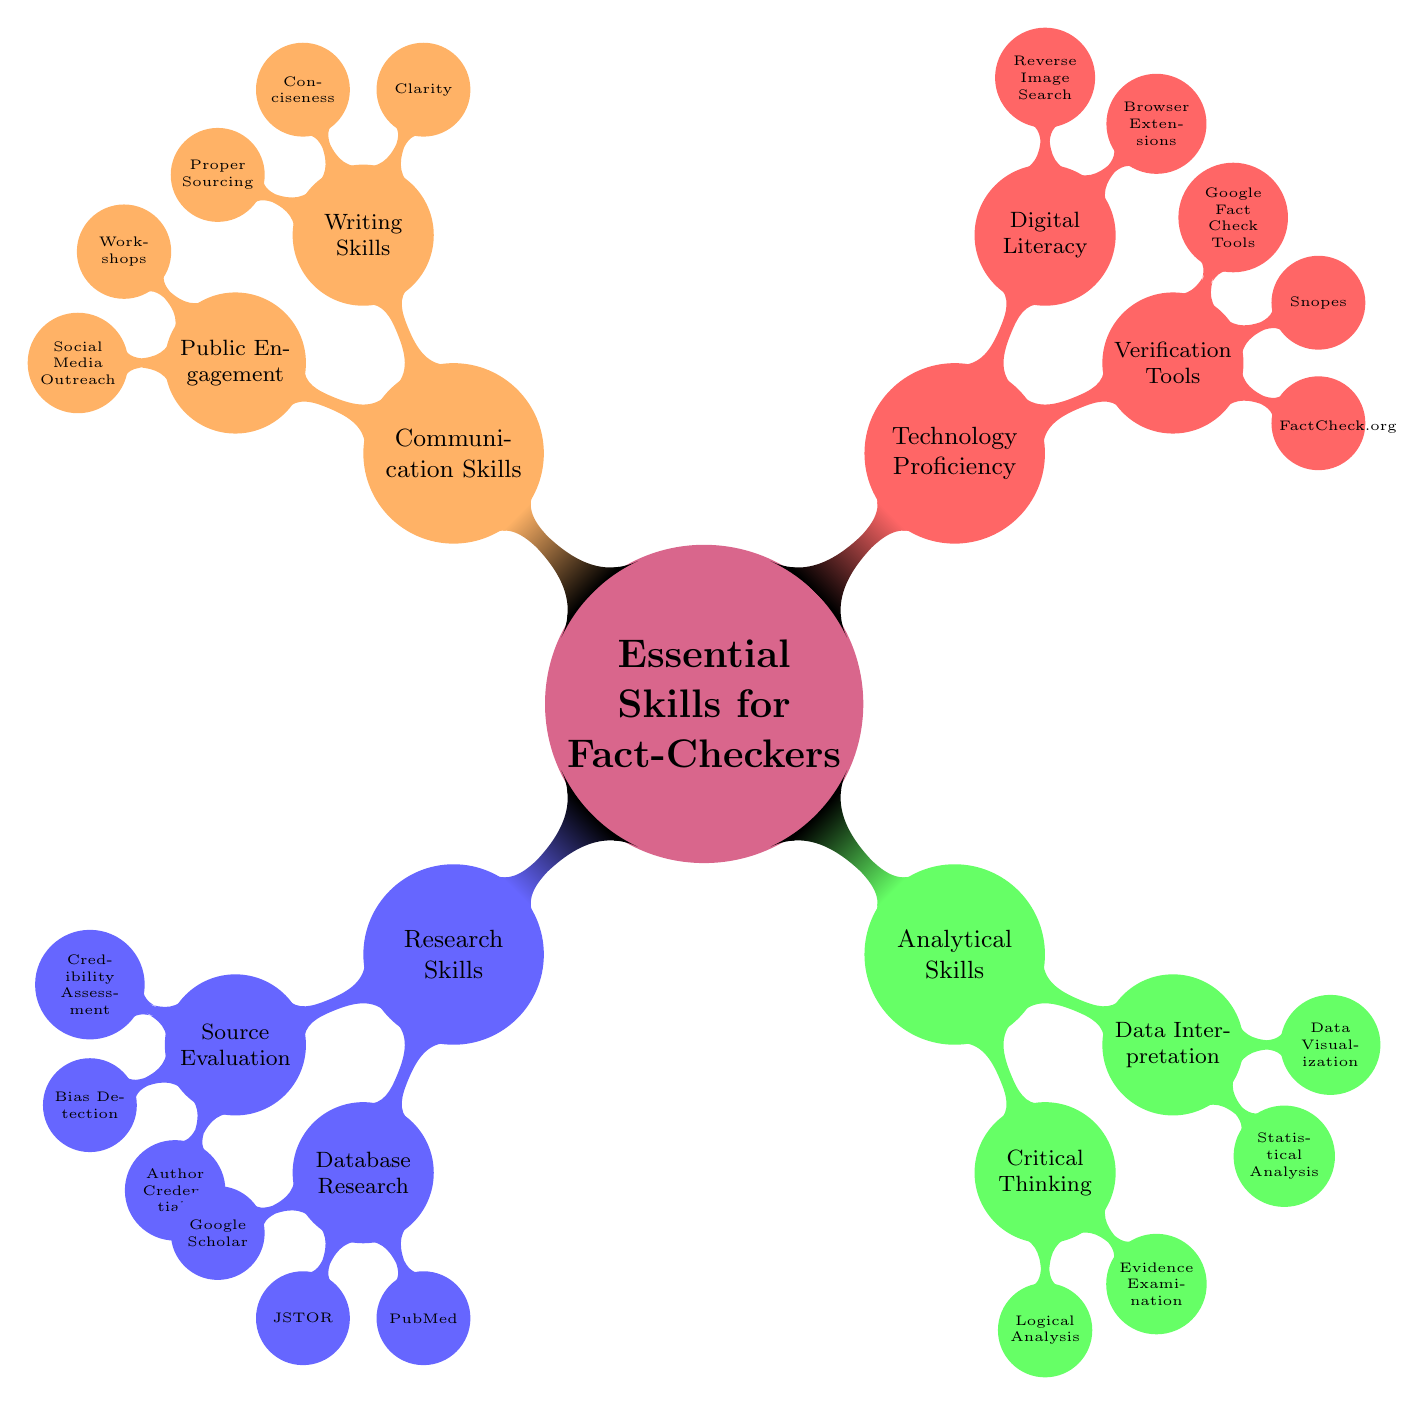What are the main categories of skills for fact-checkers? The diagram shows four main categories branching from the central node, which are Research Skills, Analytical Skills, Technology Proficiency, and Communication Skills.
Answer: Research Skills, Analytical Skills, Technology Proficiency, Communication Skills How many subnodes does "Research Skills" have? The "Research Skills" node has two subnodes: "Source Evaluation" and "Database Research." Thus, it has a total of 2 subnodes.
Answer: 2 What is a key element under "Source Evaluation"? From the "Source Evaluation" subnode, I see three elements: "Credibility Assessment," "Bias Detection," and "Author Credentials." A key element among these is "Credibility Assessment."
Answer: Credibility Assessment Which subnode under "Analytical Skills" includes "Evidence Examination"? The "Critical Thinking" subnode under "Analytical Skills" contains "Evidence Examination." This indicates its association with evaluating the validity of claims.
Answer: Critical Thinking What tools are listed under "Verification Tools"? In the "Verification Tools" subnode, the tools mentioned are "FactCheck.org," "Snopes," and "Google Fact Check Tools." Therefore, these are the tools listed.
Answer: FactCheck.org, Snopes, Google Fact Check Tools Which skill category includes "Digital Literacy"? The "Digital Literacy" node is under the "Technology Proficiency" category, indicating that it is part of the skills necessary for handling digital information effectively.
Answer: Technology Proficiency How does "Writing Skills" relate to "Public Engagement"? Both "Writing Skills" and "Public Engagement" are subnodes under the "Communication Skills" category, indicating they are equally important aspects of effective communication in the field of fact-checking.
Answer: Communication Skills What type of analysis is included in "Data Interpretation"? The "Data Interpretation" subnode includes "Statistical Analysis" and "Data Visualization," which are types of analysis important for interpreting data accurately in fact-checking.
Answer: Statistical Analysis, Data Visualization 